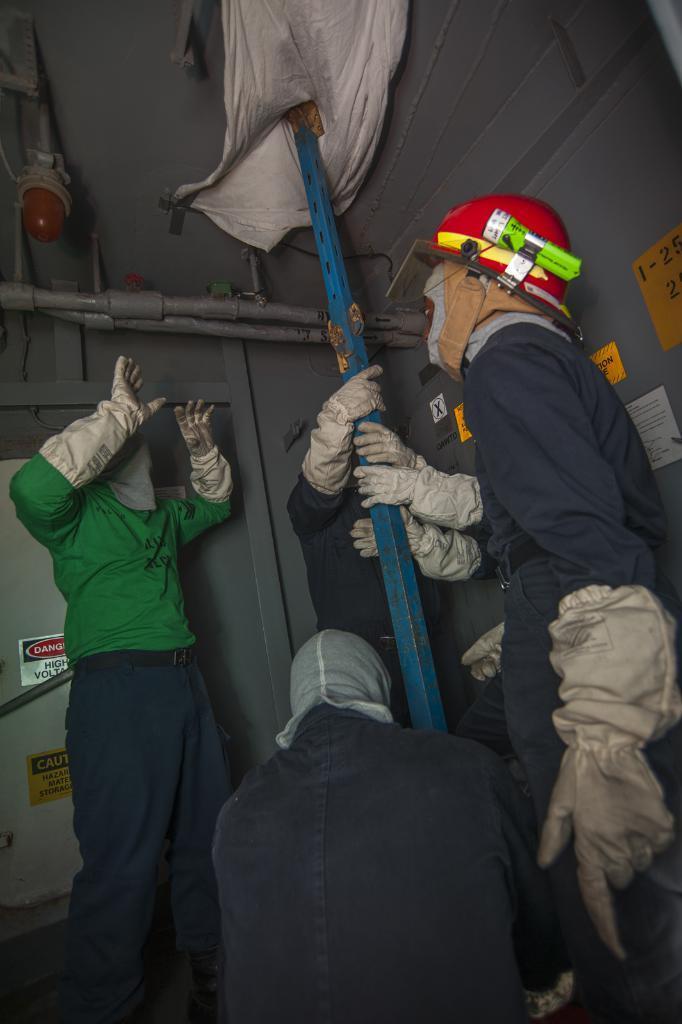Can you describe this image briefly? In the given image i can see the inside view of the house that includes people,metal rod,cloth,light and pipes. 